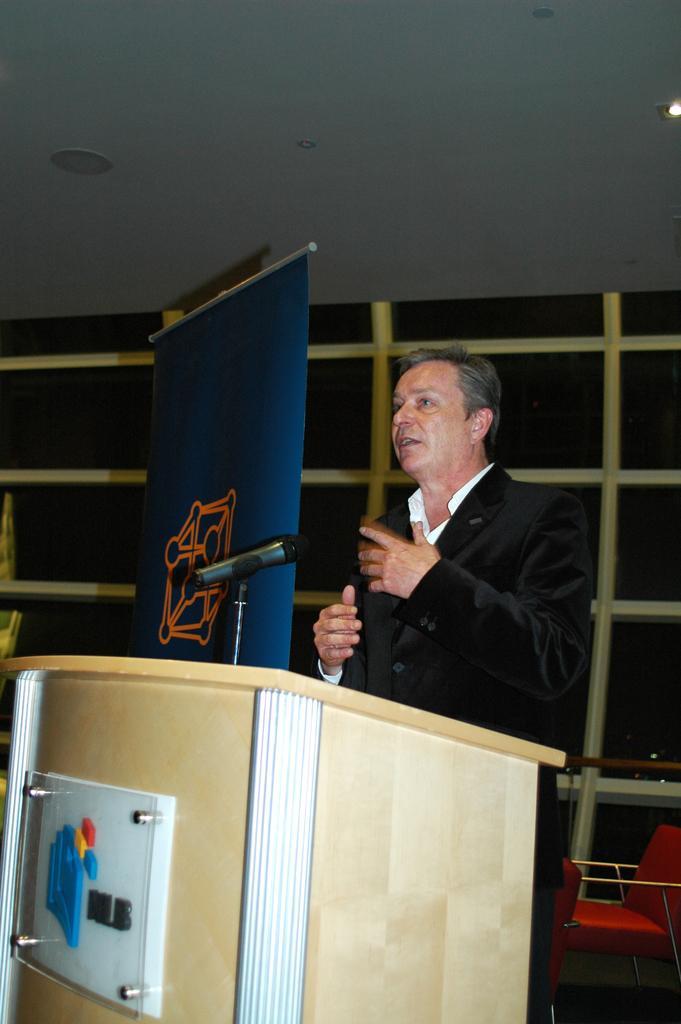How would you summarize this image in a sentence or two? In this picture I can see a man standing near the podium, there is a mike, banner, there are chairs, and in the background there is a wall. 